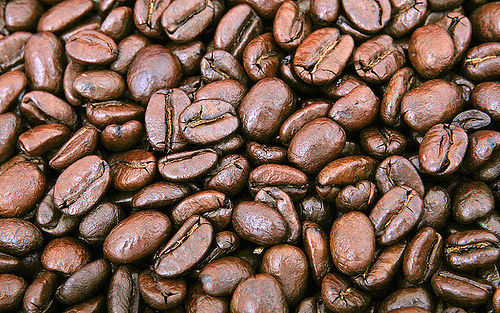<image>
Can you confirm if the bean is in the bean? No. The bean is not contained within the bean. These objects have a different spatial relationship. 